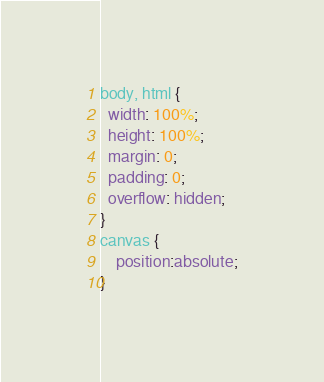Convert code to text. <code><loc_0><loc_0><loc_500><loc_500><_CSS_>body, html {
  width: 100%;
  height: 100%;
  margin: 0;
  padding: 0;
  overflow: hidden;
}
canvas {
    position:absolute;
}</code> 